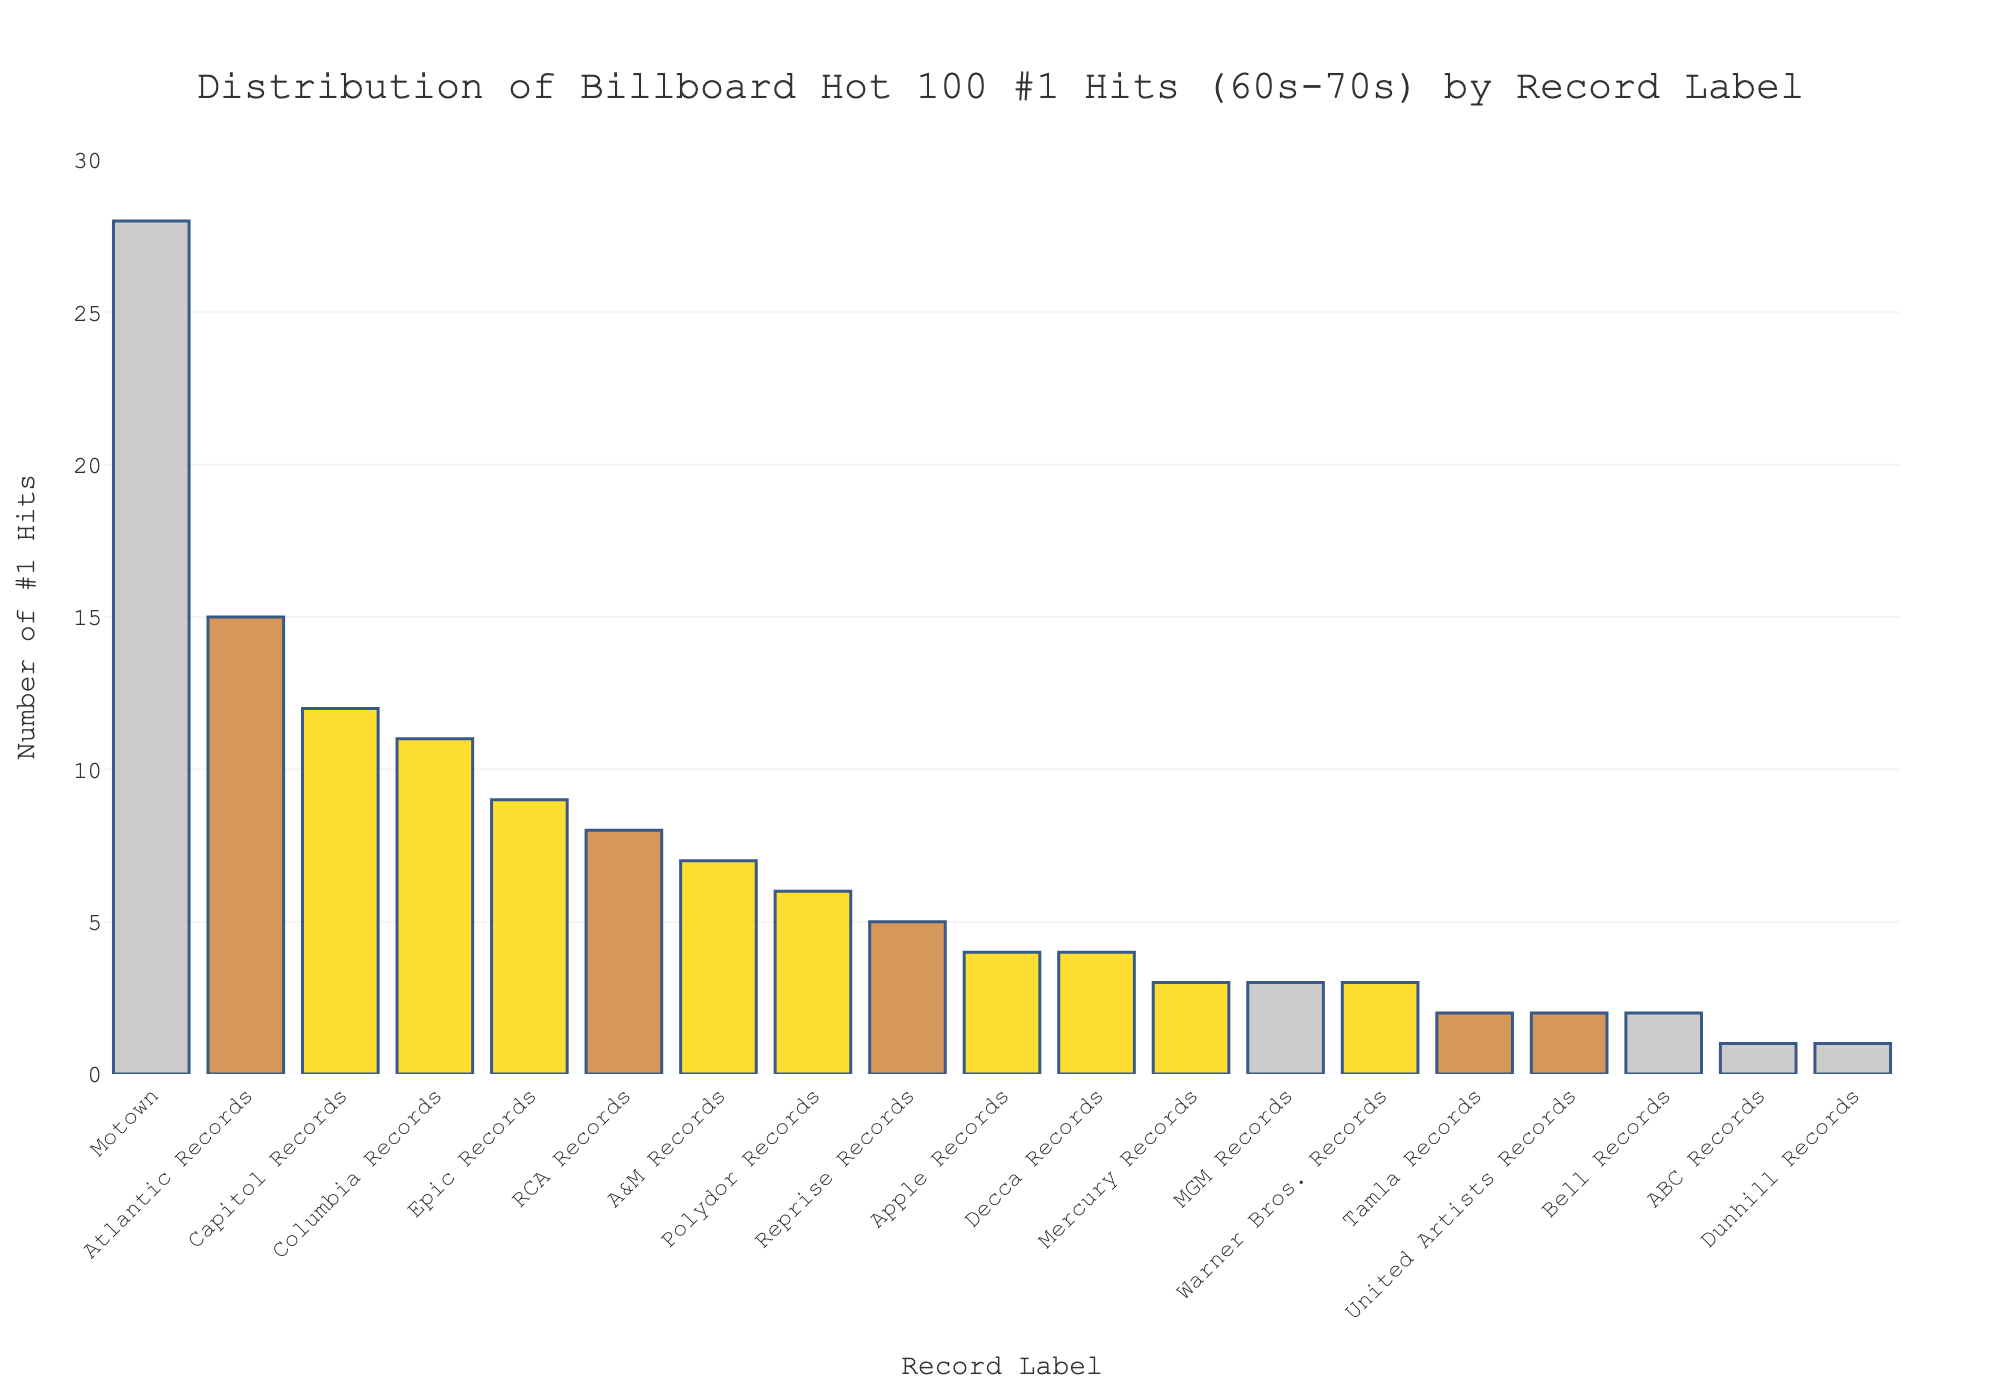What record label has the highest number of #1 hits? To find the label with the highest number of #1 hits, look for the tallest bar in the bar chart. In this case, the tallest bar corresponds to Motown.
Answer: Motown How many more #1 hits did Motown have compared to Atlantic Records? Motown has 28 #1 hits and Atlantic Records has 15. Subtract the number of hits for Atlantic Records from the number for Motown: 28 - 15.
Answer: 13 What is the total number of #1 hits for the top three record labels? The top three record labels are Motown (28), Atlantic Records (15), and Capitol Records (12). Summing these values: 28 + 15 + 12.
Answer: 55 Which record labels have less than 5 #1 hits and how many do they have in total? The record labels with fewer than 5 #1 hits are Decca Records (4), Apple Records (4), Mercury Records (3), MGM Records (3), Warner Bros. Records (3), Tamla Records (2), United Artists Records (2), Bell Records (2), ABC Records (1), and Dunhill Records (1). Adding these values: 4 + 4 + 3 + 3 + 3 + 2 + 2 + 2 + 1 + 1.
Answer: 25 What percentage of the total #1 hits do Motown’s hits represent? First, find the total number of #1 hits by summing all the hits. Total = 28 + 15 + 12 + 11 + 9 + 8 + 7 + 6 + 5 + 4 + 4 + 3 + 3 + 3 + 2 + 2 + 2 + 1 + 1. Then, divide Motown’s hits by this total and multiply by 100 to get the percentage: (28 / 128) * 100.
Answer: 21.88% How many record labels have 5 or more #1 hits? Count the number of bars that have a height corresponding to 5 or more #1 hits. The labels are Motown, Atlantic Records, Capitol Records, Columbia Records, Epic Records, RCA Records, A&M Records, Polydor Records, and Reprise Records.
Answer: 9 What is the difference in the number of #1 hits between the record label with the smallest and largest number of #1 hits? The record label with the smallest number of #1 hits (among those listed) is ABC Records and Dunhill Records (1 each), while the label with the largest number is Motown (28). Subtract the smallest value from the largest: 28 - 1.
Answer: 27 What is the average number of #1 hits per record label? Total the number of #1 hits for all labels and divide by the number of labels. Total hits = 128, and the number of labels is 19. So, calculate 128 / 19.
Answer: 6.74 Which record labels have exactly 3 #1 hits? Identify the bars that have a height corresponding to 3 #1 hits. The labels are Mercury Records, MGM Records, and Warner Bros. Records.
Answer: Mercury Records, MGM Records, Warner Bros. Records Are there any record labels with exactly 10 #1 hits? Scan the bars and their corresponding labels to see if any bar's height indicates exactly 10 #1 hits. None of the bars correspond to 10 #1 hits.
Answer: No 